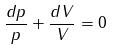<formula> <loc_0><loc_0><loc_500><loc_500>\frac { d p } { p } + \frac { d V } { V } = 0</formula> 